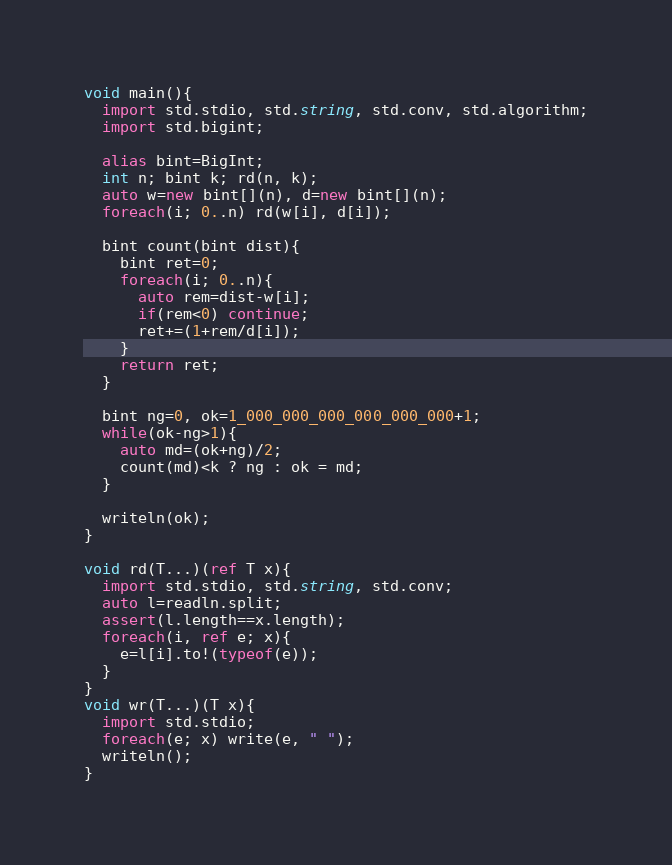Convert code to text. <code><loc_0><loc_0><loc_500><loc_500><_D_>void main(){
  import std.stdio, std.string, std.conv, std.algorithm;
  import std.bigint;

  alias bint=BigInt;
  int n; bint k; rd(n, k);
  auto w=new bint[](n), d=new bint[](n);
  foreach(i; 0..n) rd(w[i], d[i]);

  bint count(bint dist){
    bint ret=0;
    foreach(i; 0..n){
      auto rem=dist-w[i];
      if(rem<0) continue;
      ret+=(1+rem/d[i]);
    }
    return ret;
  }

  bint ng=0, ok=1_000_000_000_000_000_000+1;
  while(ok-ng>1){
    auto md=(ok+ng)/2;
    count(md)<k ? ng : ok = md;
  }

  writeln(ok);
}

void rd(T...)(ref T x){
  import std.stdio, std.string, std.conv;
  auto l=readln.split;
  assert(l.length==x.length);
  foreach(i, ref e; x){
    e=l[i].to!(typeof(e));
  }
}
void wr(T...)(T x){
  import std.stdio;
  foreach(e; x) write(e, " ");
  writeln();
}</code> 